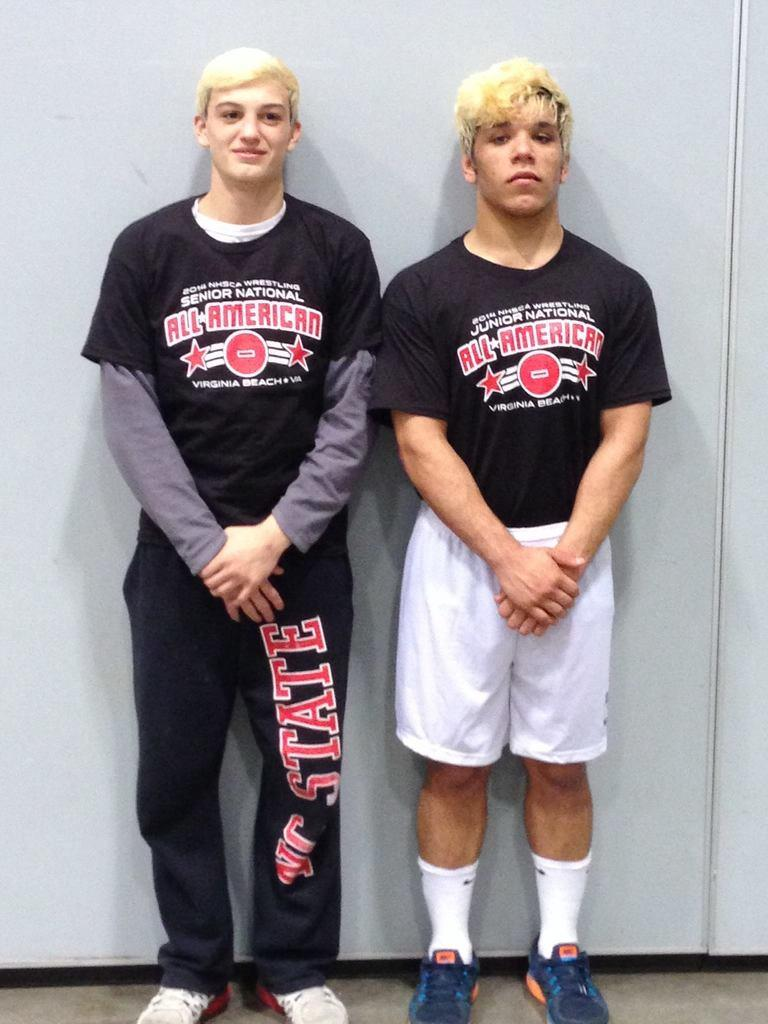<image>
Create a compact narrative representing the image presented. Two young men with blonde hair stand together and are both wearing "All American" shirts. 